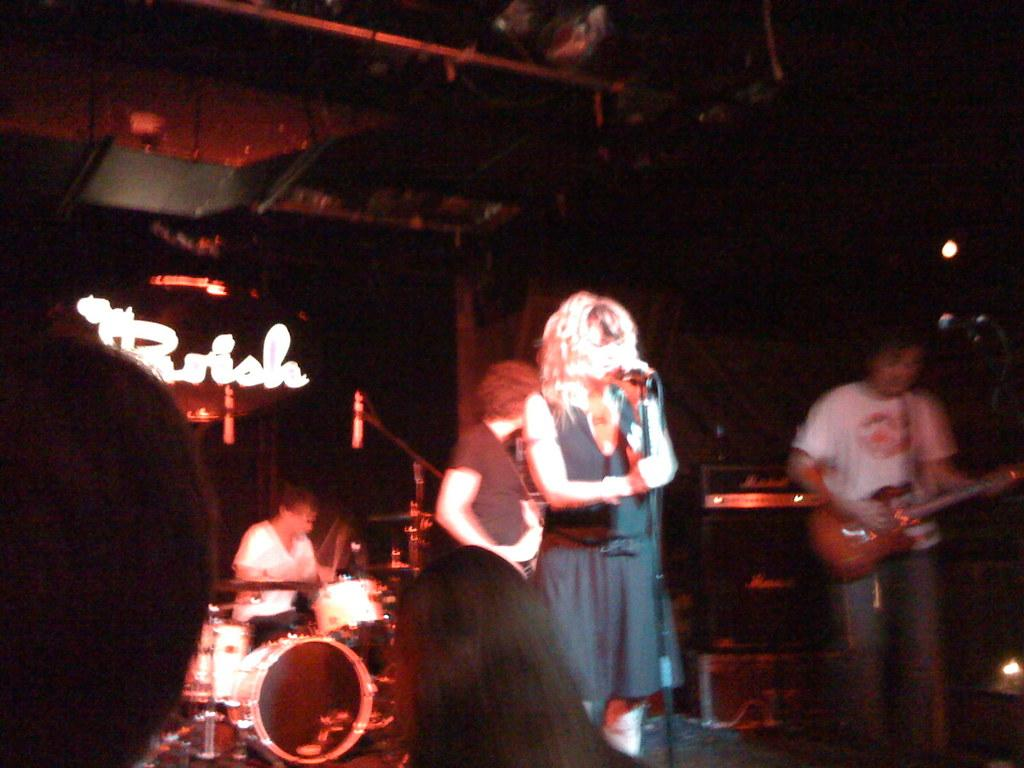Who or what can be seen in the image? There are people in the image. What are the people doing in the image? Musical instruments are present in the image, and a man is holding a guitar with his hands. What tools are used for amplifying sound in the image? Microphones (mics) are visible in the image. What can be seen in the background of the image? The background of the image is dark. What other objects are present in the image besides the people and musical instruments? Lights are present in the image. Can you see a friend holding a rod in the image? There is no friend or rod present in the image. 